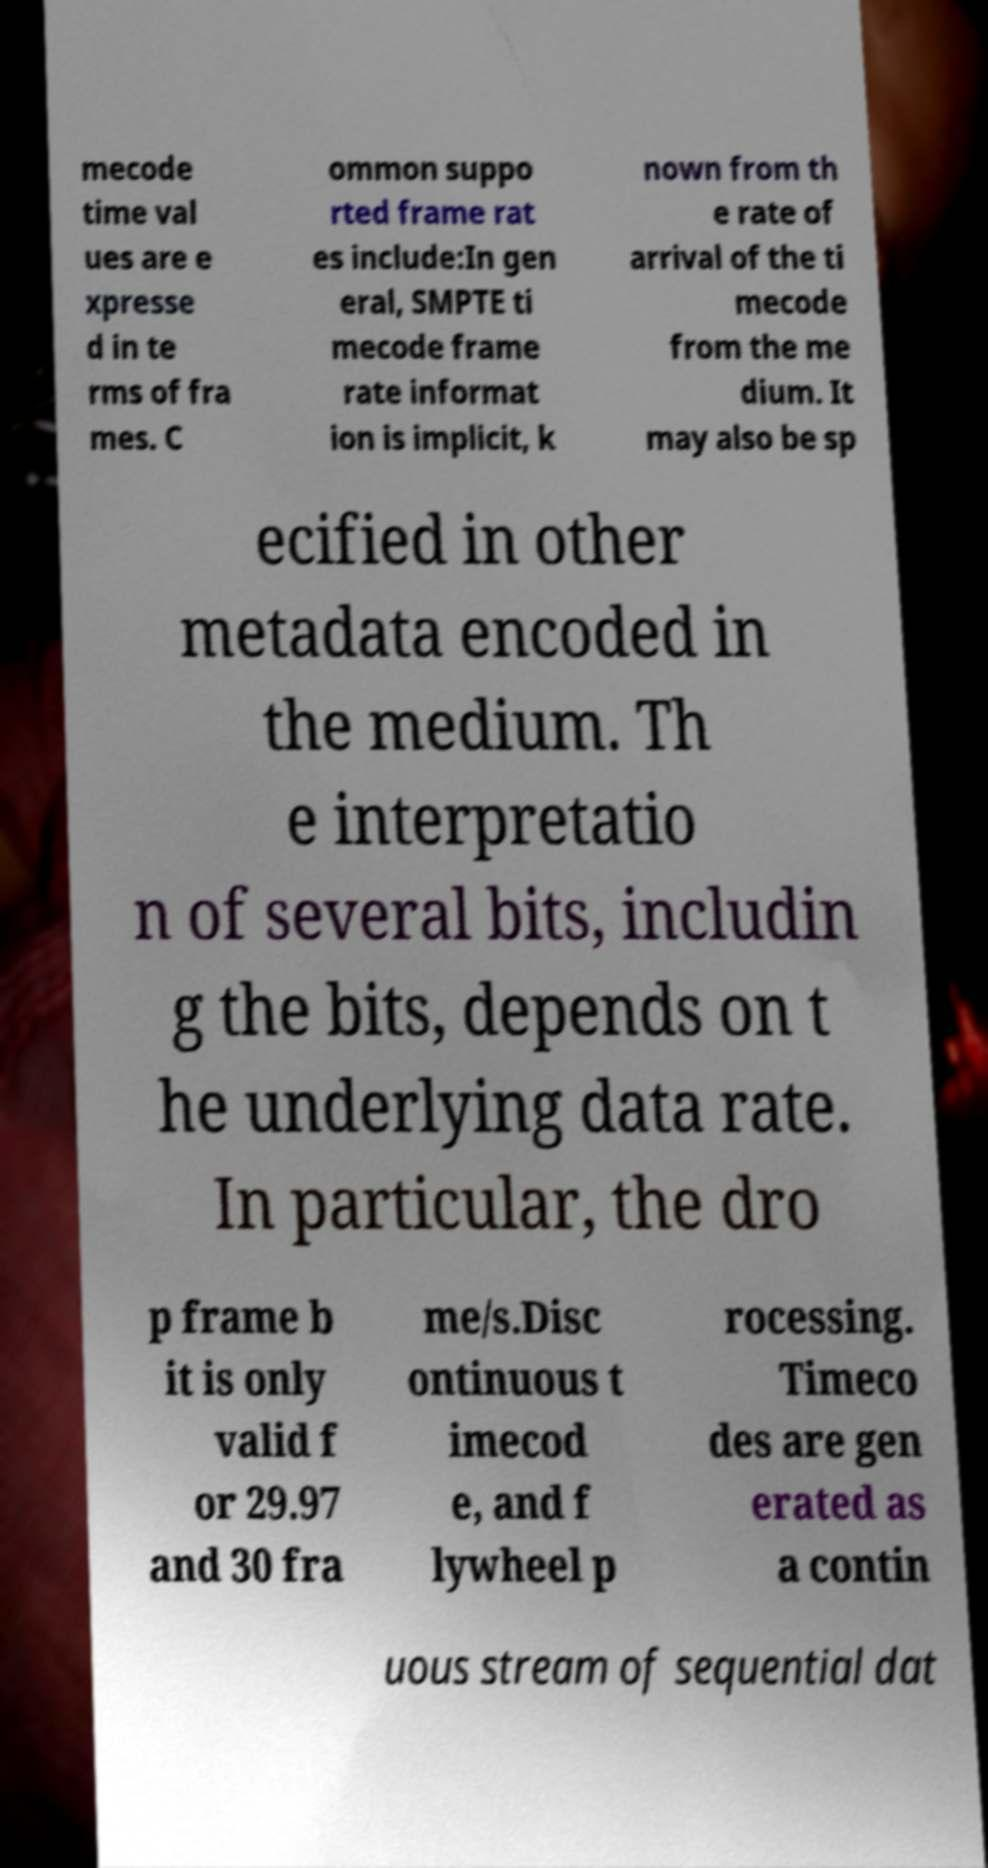Please read and relay the text visible in this image. What does it say? mecode time val ues are e xpresse d in te rms of fra mes. C ommon suppo rted frame rat es include:In gen eral, SMPTE ti mecode frame rate informat ion is implicit, k nown from th e rate of arrival of the ti mecode from the me dium. It may also be sp ecified in other metadata encoded in the medium. Th e interpretatio n of several bits, includin g the bits, depends on t he underlying data rate. In particular, the dro p frame b it is only valid f or 29.97 and 30 fra me/s.Disc ontinuous t imecod e, and f lywheel p rocessing. Timeco des are gen erated as a contin uous stream of sequential dat 